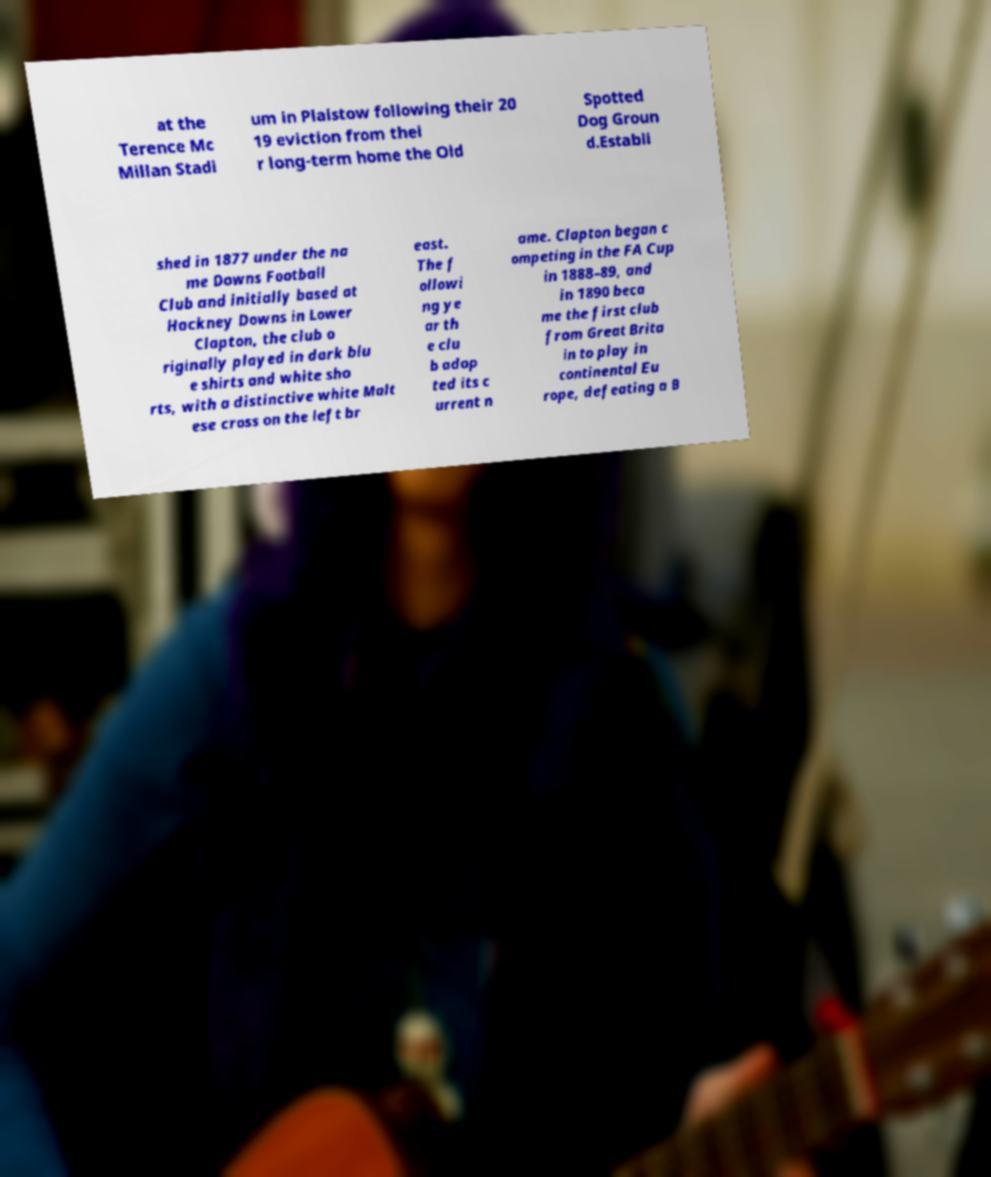Can you read and provide the text displayed in the image?This photo seems to have some interesting text. Can you extract and type it out for me? at the Terence Mc Millan Stadi um in Plaistow following their 20 19 eviction from thei r long-term home the Old Spotted Dog Groun d.Establi shed in 1877 under the na me Downs Football Club and initially based at Hackney Downs in Lower Clapton, the club o riginally played in dark blu e shirts and white sho rts, with a distinctive white Malt ese cross on the left br east. The f ollowi ng ye ar th e clu b adop ted its c urrent n ame. Clapton began c ompeting in the FA Cup in 1888–89, and in 1890 beca me the first club from Great Brita in to play in continental Eu rope, defeating a B 